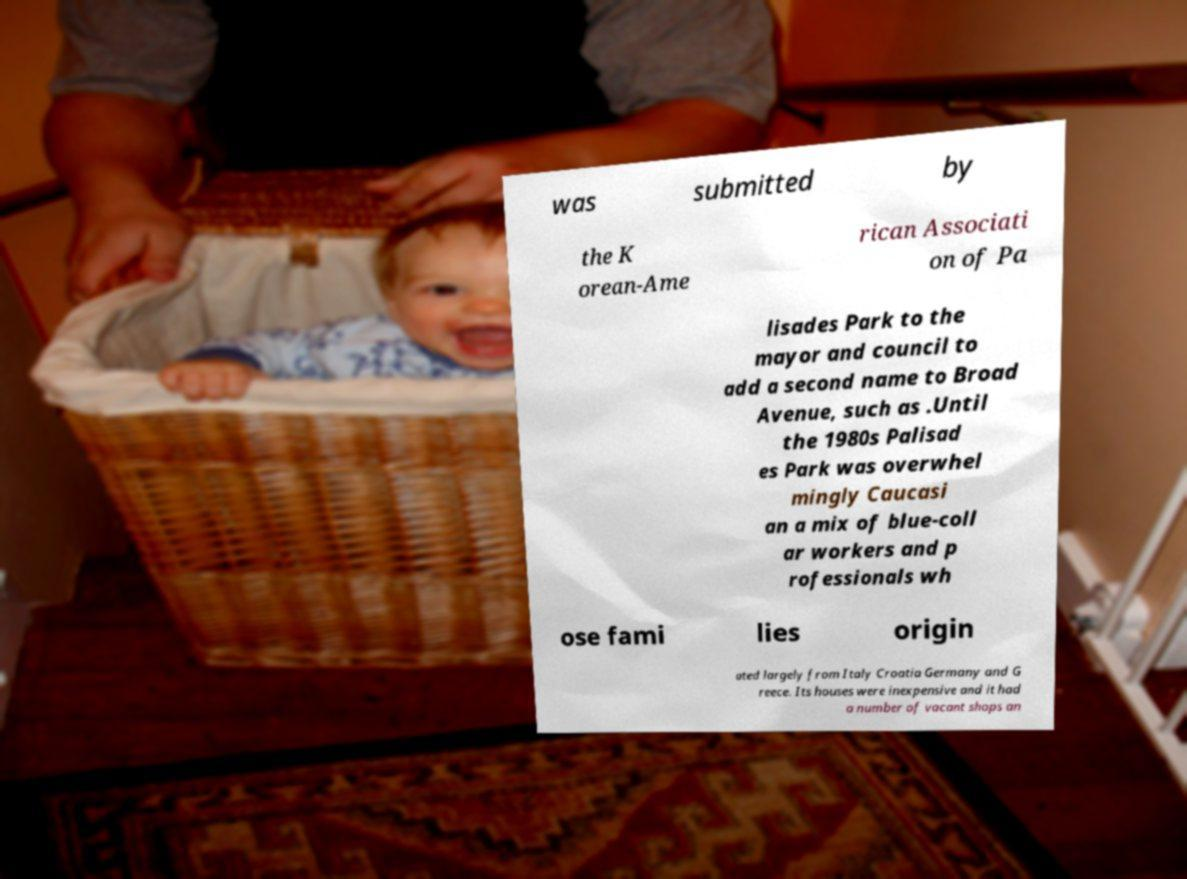What messages or text are displayed in this image? I need them in a readable, typed format. was submitted by the K orean-Ame rican Associati on of Pa lisades Park to the mayor and council to add a second name to Broad Avenue, such as .Until the 1980s Palisad es Park was overwhel mingly Caucasi an a mix of blue-coll ar workers and p rofessionals wh ose fami lies origin ated largely from Italy Croatia Germany and G reece. Its houses were inexpensive and it had a number of vacant shops an 